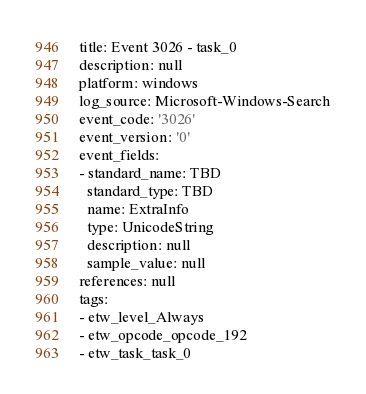Convert code to text. <code><loc_0><loc_0><loc_500><loc_500><_YAML_>title: Event 3026 - task_0
description: null
platform: windows
log_source: Microsoft-Windows-Search
event_code: '3026'
event_version: '0'
event_fields:
- standard_name: TBD
  standard_type: TBD
  name: ExtraInfo
  type: UnicodeString
  description: null
  sample_value: null
references: null
tags:
- etw_level_Always
- etw_opcode_opcode_192
- etw_task_task_0
</code> 